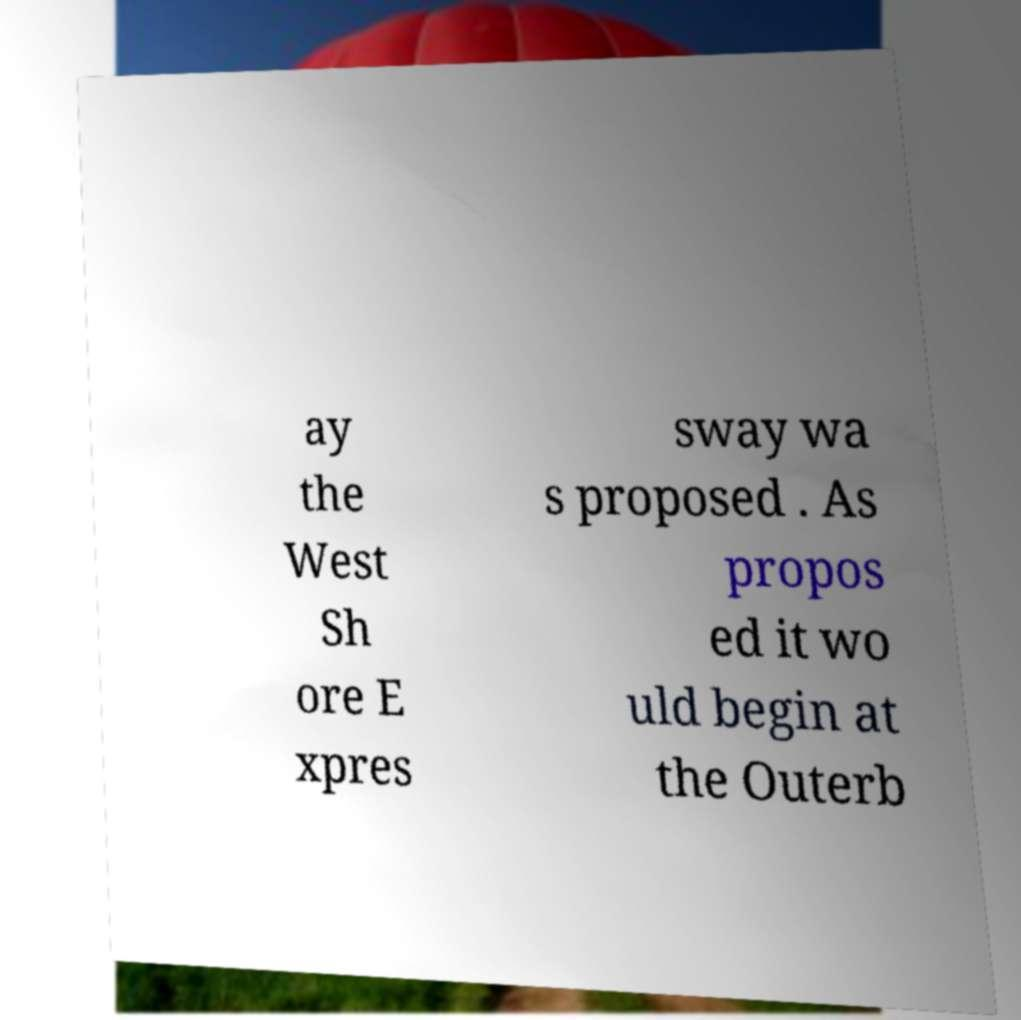For documentation purposes, I need the text within this image transcribed. Could you provide that? ay the West Sh ore E xpres sway wa s proposed . As propos ed it wo uld begin at the Outerb 